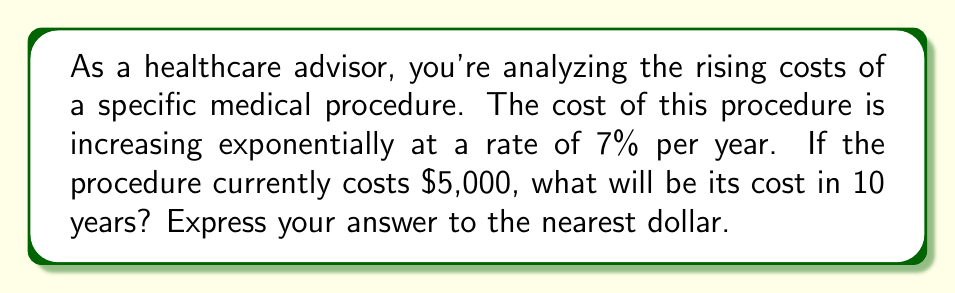Teach me how to tackle this problem. Let's approach this step-by-step using an exponential function:

1) The general form of an exponential function is:
   $$ A(t) = A_0 \cdot (1 + r)^t $$
   where:
   $A(t)$ is the amount after time $t$
   $A_0$ is the initial amount
   $r$ is the growth rate (as a decimal)
   $t$ is the time period

2) In this case:
   $A_0 = 5000$ (initial cost)
   $r = 0.07$ (7% growth rate)
   $t = 10$ (years)

3) Plugging these values into our function:
   $$ A(10) = 5000 \cdot (1 + 0.07)^{10} $$

4) Calculate:
   $$ A(10) = 5000 \cdot (1.07)^{10} $$
   $$ A(10) = 5000 \cdot 1.9672165... $$
   $$ A(10) = 9836.08... $$

5) Rounding to the nearest dollar:
   $$ A(10) \approx 9836 $$
Answer: $9,836 